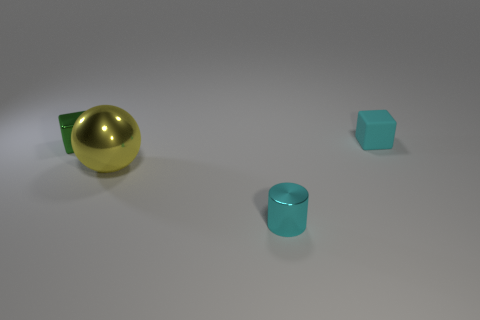Subtract all red cubes. Subtract all red balls. How many cubes are left? 2 Add 3 small green metallic things. How many objects exist? 7 Subtract all balls. How many objects are left? 3 Subtract all tiny cylinders. Subtract all blocks. How many objects are left? 1 Add 4 large yellow balls. How many large yellow balls are left? 5 Add 4 green balls. How many green balls exist? 4 Subtract 1 cyan cylinders. How many objects are left? 3 